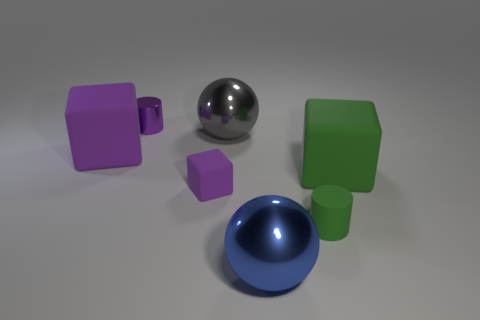Does the large thing that is on the left side of the gray ball have the same material as the tiny object that is behind the gray metal ball?
Offer a very short reply. No. How many purple rubber objects are there?
Your answer should be very brief. 2. There is a thing that is in front of the small green cylinder; what is its shape?
Give a very brief answer. Sphere. What number of other things are the same size as the purple cylinder?
Ensure brevity in your answer.  2. Does the big object to the right of the small green thing have the same shape as the tiny matte object left of the big gray metallic ball?
Give a very brief answer. Yes. How many large gray metallic balls are on the left side of the gray sphere?
Offer a terse response. 0. There is a large matte thing on the right side of the tiny purple shiny cylinder; what is its color?
Your answer should be very brief. Green. What is the color of the other big thing that is the same shape as the large purple matte thing?
Ensure brevity in your answer.  Green. Is there any other thing that has the same color as the small matte cylinder?
Provide a succinct answer. Yes. Is the number of big metallic objects greater than the number of yellow shiny cubes?
Provide a succinct answer. Yes. 